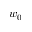Convert formula to latex. <formula><loc_0><loc_0><loc_500><loc_500>w _ { 0 }</formula> 